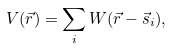Convert formula to latex. <formula><loc_0><loc_0><loc_500><loc_500>V ( { \vec { r } } ) = \sum _ { i } W ( { \vec { r } } - { \vec { s } } _ { i } ) ,</formula> 